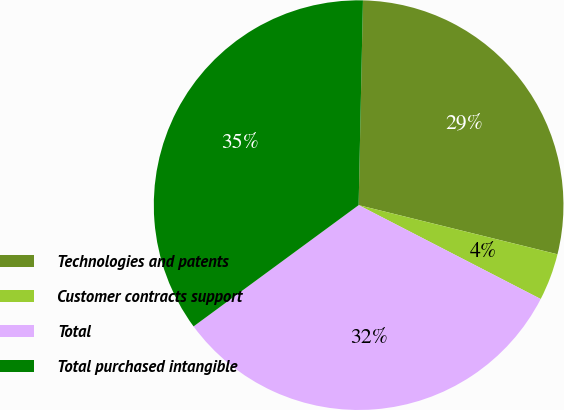Convert chart to OTSL. <chart><loc_0><loc_0><loc_500><loc_500><pie_chart><fcel>Technologies and patents<fcel>Customer contracts support<fcel>Total<fcel>Total purchased intangible<nl><fcel>28.52%<fcel>3.72%<fcel>32.34%<fcel>35.42%<nl></chart> 